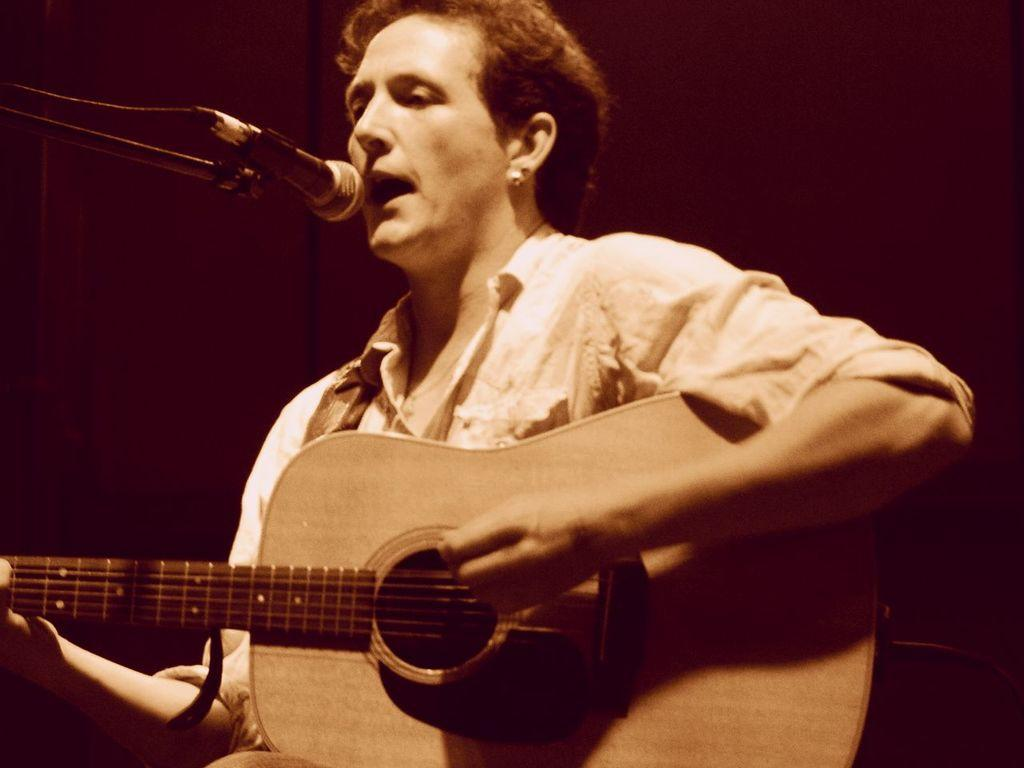What is the person in the image doing? The person in the image is playing the guitar and appears to be singing a song. What object is in front of the person? There is a microphone stand in front of the person. What type of quince is being used as a prop in the image? There is no quince present in the image; it features a person playing the guitar and singing with a microphone stand. What is the person's opinion on the topic of star formation? The image does not provide any information about the person's opinion on star formation or any other topic. 